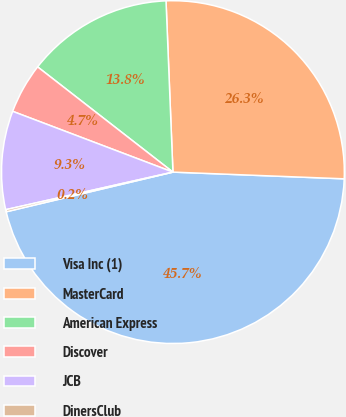Convert chart to OTSL. <chart><loc_0><loc_0><loc_500><loc_500><pie_chart><fcel>Visa Inc (1)<fcel>MasterCard<fcel>American Express<fcel>Discover<fcel>JCB<fcel>DinersClub<nl><fcel>45.66%<fcel>26.27%<fcel>13.84%<fcel>4.75%<fcel>9.29%<fcel>0.2%<nl></chart> 